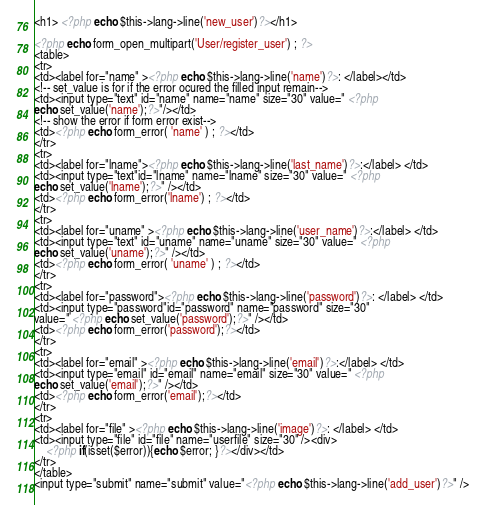<code> <loc_0><loc_0><loc_500><loc_500><_PHP_><h1> <?php echo $this->lang->line('new_user')?></h1>

<?php echo form_open_multipart('User/register_user') ; ?>
<table>
<tr>
<td><label for="name" ><?php echo $this->lang->line('name')?>: </label></td>
<!-- set_value is for if the error ocured the filled input remain-->
<td><input type="text" id="name" name="name" size="30" value=" <?php
echo set_value('name');?>"/></td>
<!-- show the error if form error exist-->
<td><?php echo form_error( 'name' ) ; ?></td>
</tr>
<tr>
<td><label for="lname"><?php echo $this->lang->line('last_name')?>:</label> </td>
<td><input type="text"id="lname" name="lname" size="30" value=" <?php
echo set_value('lname');?>" /></td>
<td><?php echo form_error('lname') ; ?></td>
</tr>
<tr>
<td><label for="uname" ><?php echo $this->lang->line('user_name')?>:</label> </td>
<td><input type="text" id="uname" name="uname" size="30" value=" <?php
echo set_value('uname');?>" /></td>
<td><?php echo form_error( 'uname' ) ; ?></td>
</tr>
<tr>
<td><label for="password"><?php echo $this->lang->line('password')?>: </label> </td>
<td><input type="password"id="password" name="password" size="30"
value=" <?php echo set_value('password');?>" /></td>
<td><?php echo form_error('password');?></td>
</tr>
<tr>
<td><label for="email" ><?php echo $this->lang->line('email')?>:</label> </td>
<td><input type="email" id="email" name="email" size="30" value=" <?php
echo set_value('email');?>" /></td>
<td><?php echo form_error('email');?></td>
</tr>
<tr>
<td><label for="file" ><?php echo $this->lang->line('image')?>: </label> </td>
<td><input type="file" id="file" name="userfile" size="30" /><div> 
    <?php if(isset($error)){echo $error; }?></div></td>
</tr>
</table>
<input type="submit" name="submit" value="<?php echo $this->lang->line('add_user')?>" />




</code> 